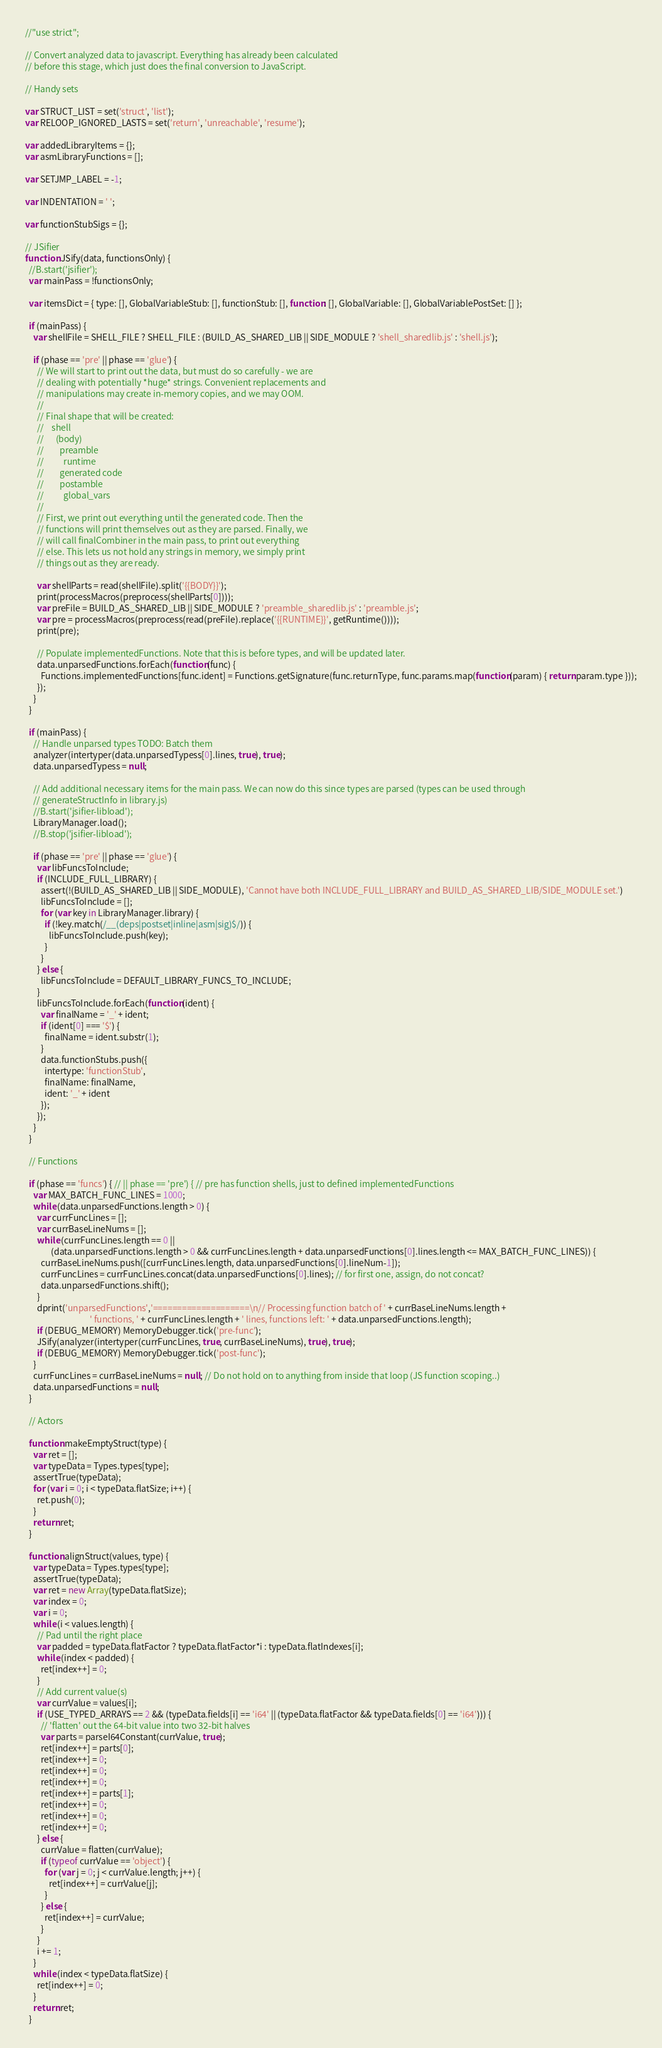Convert code to text. <code><loc_0><loc_0><loc_500><loc_500><_JavaScript_>//"use strict";

// Convert analyzed data to javascript. Everything has already been calculated
// before this stage, which just does the final conversion to JavaScript.

// Handy sets

var STRUCT_LIST = set('struct', 'list');
var RELOOP_IGNORED_LASTS = set('return', 'unreachable', 'resume');

var addedLibraryItems = {};
var asmLibraryFunctions = [];

var SETJMP_LABEL = -1;

var INDENTATION = ' ';

var functionStubSigs = {};

// JSifier
function JSify(data, functionsOnly) {
  //B.start('jsifier');
  var mainPass = !functionsOnly;

  var itemsDict = { type: [], GlobalVariableStub: [], functionStub: [], function: [], GlobalVariable: [], GlobalVariablePostSet: [] };

  if (mainPass) {
    var shellFile = SHELL_FILE ? SHELL_FILE : (BUILD_AS_SHARED_LIB || SIDE_MODULE ? 'shell_sharedlib.js' : 'shell.js');

    if (phase == 'pre' || phase == 'glue') {
      // We will start to print out the data, but must do so carefully - we are
      // dealing with potentially *huge* strings. Convenient replacements and
      // manipulations may create in-memory copies, and we may OOM.
      //
      // Final shape that will be created:
      //    shell
      //      (body)
      //        preamble
      //          runtime
      //        generated code
      //        postamble
      //          global_vars
      //
      // First, we print out everything until the generated code. Then the
      // functions will print themselves out as they are parsed. Finally, we
      // will call finalCombiner in the main pass, to print out everything
      // else. This lets us not hold any strings in memory, we simply print
      // things out as they are ready.

      var shellParts = read(shellFile).split('{{BODY}}');
      print(processMacros(preprocess(shellParts[0])));
      var preFile = BUILD_AS_SHARED_LIB || SIDE_MODULE ? 'preamble_sharedlib.js' : 'preamble.js';
      var pre = processMacros(preprocess(read(preFile).replace('{{RUNTIME}}', getRuntime())));
      print(pre);

      // Populate implementedFunctions. Note that this is before types, and will be updated later.
      data.unparsedFunctions.forEach(function(func) {
        Functions.implementedFunctions[func.ident] = Functions.getSignature(func.returnType, func.params.map(function(param) { return param.type }));
      });
    }
  }

  if (mainPass) {
    // Handle unparsed types TODO: Batch them
    analyzer(intertyper(data.unparsedTypess[0].lines, true), true);
    data.unparsedTypess = null;

    // Add additional necessary items for the main pass. We can now do this since types are parsed (types can be used through
    // generateStructInfo in library.js)
    //B.start('jsifier-libload');
    LibraryManager.load();
    //B.stop('jsifier-libload');

    if (phase == 'pre' || phase == 'glue') {
      var libFuncsToInclude;
      if (INCLUDE_FULL_LIBRARY) {
        assert(!(BUILD_AS_SHARED_LIB || SIDE_MODULE), 'Cannot have both INCLUDE_FULL_LIBRARY and BUILD_AS_SHARED_LIB/SIDE_MODULE set.')
        libFuncsToInclude = [];
        for (var key in LibraryManager.library) {
          if (!key.match(/__(deps|postset|inline|asm|sig)$/)) {
            libFuncsToInclude.push(key);
          }
        }
      } else {
        libFuncsToInclude = DEFAULT_LIBRARY_FUNCS_TO_INCLUDE;
      }
      libFuncsToInclude.forEach(function(ident) {
        var finalName = '_' + ident;
        if (ident[0] === '$') {
          finalName = ident.substr(1);
        }
        data.functionStubs.push({
          intertype: 'functionStub',
          finalName: finalName,
          ident: '_' + ident
        });
      });
    }
  }

  // Functions

  if (phase == 'funcs') { // || phase == 'pre') { // pre has function shells, just to defined implementedFunctions
    var MAX_BATCH_FUNC_LINES = 1000;
    while (data.unparsedFunctions.length > 0) {
      var currFuncLines = [];
      var currBaseLineNums = [];
      while (currFuncLines.length == 0 ||
             (data.unparsedFunctions.length > 0 && currFuncLines.length + data.unparsedFunctions[0].lines.length <= MAX_BATCH_FUNC_LINES)) {
        currBaseLineNums.push([currFuncLines.length, data.unparsedFunctions[0].lineNum-1]);
        currFuncLines = currFuncLines.concat(data.unparsedFunctions[0].lines); // for first one, assign, do not concat?
        data.unparsedFunctions.shift();
      }
      dprint('unparsedFunctions','====================\n// Processing function batch of ' + currBaseLineNums.length +
                                 ' functions, ' + currFuncLines.length + ' lines, functions left: ' + data.unparsedFunctions.length);
      if (DEBUG_MEMORY) MemoryDebugger.tick('pre-func');
      JSify(analyzer(intertyper(currFuncLines, true, currBaseLineNums), true), true);
      if (DEBUG_MEMORY) MemoryDebugger.tick('post-func');
    }
    currFuncLines = currBaseLineNums = null; // Do not hold on to anything from inside that loop (JS function scoping..)
    data.unparsedFunctions = null;
  }

  // Actors

  function makeEmptyStruct(type) {
    var ret = [];
    var typeData = Types.types[type];
    assertTrue(typeData);
    for (var i = 0; i < typeData.flatSize; i++) {
      ret.push(0);
    }
    return ret;
  }

  function alignStruct(values, type) {
    var typeData = Types.types[type];
    assertTrue(typeData);
    var ret = new Array(typeData.flatSize);
    var index = 0;
    var i = 0;
    while (i < values.length) {
      // Pad until the right place
      var padded = typeData.flatFactor ? typeData.flatFactor*i : typeData.flatIndexes[i];
      while (index < padded) {
        ret[index++] = 0;
      }
      // Add current value(s)
      var currValue = values[i];
      if (USE_TYPED_ARRAYS == 2 && (typeData.fields[i] == 'i64' || (typeData.flatFactor && typeData.fields[0] == 'i64'))) {
        // 'flatten' out the 64-bit value into two 32-bit halves
        var parts = parseI64Constant(currValue, true);
        ret[index++] = parts[0];
        ret[index++] = 0;
        ret[index++] = 0;
        ret[index++] = 0;
        ret[index++] = parts[1];
        ret[index++] = 0;
        ret[index++] = 0;
        ret[index++] = 0;
      } else {
        currValue = flatten(currValue);
        if (typeof currValue == 'object') {
          for (var j = 0; j < currValue.length; j++) {
            ret[index++] = currValue[j];
          }
        } else {
          ret[index++] = currValue;
        }
      }
      i += 1;
    }
    while (index < typeData.flatSize) {
      ret[index++] = 0;
    }
    return ret;
  }
</code> 